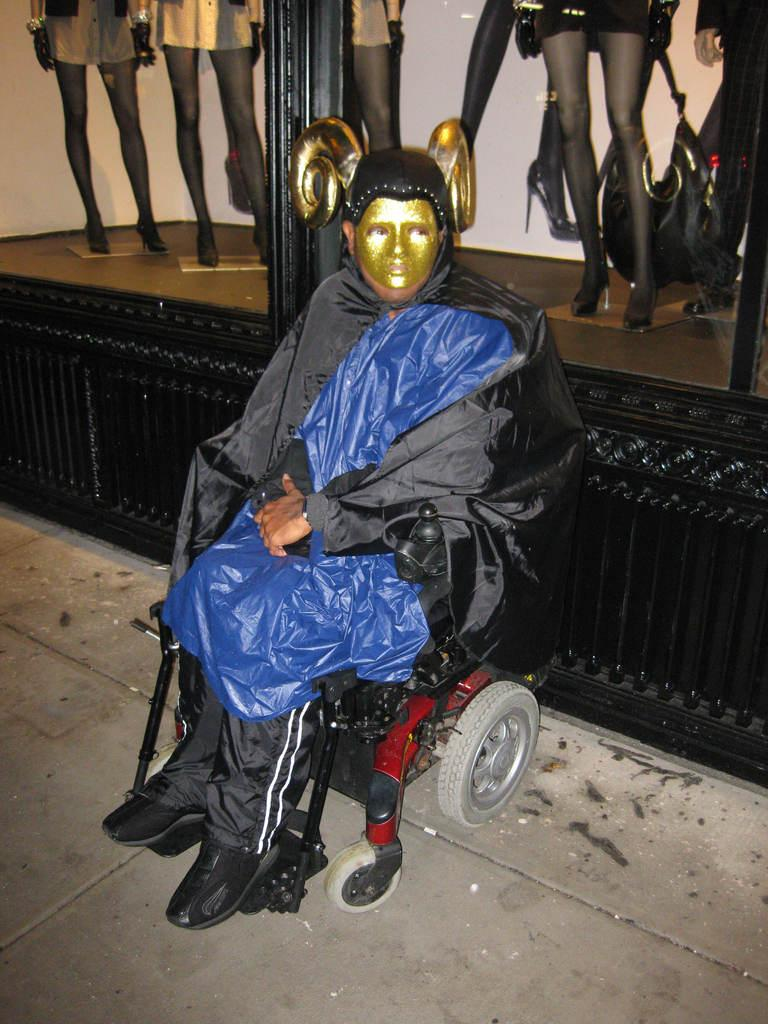Who is present in the image? There is a person in the image. What is the person wearing? The person is wearing a blue and black colored dress and a gold colored mask. What is the person doing in the image? The person is sitting on a chair. What can be seen in the background of the image? There are mannequins in the background of the image. How many sisters does the person in the image have? There is no information about the person's sisters in the image. Can you tell me if the person in the image is about to sneeze? There is no indication in the image that the person is about to sneeze. 